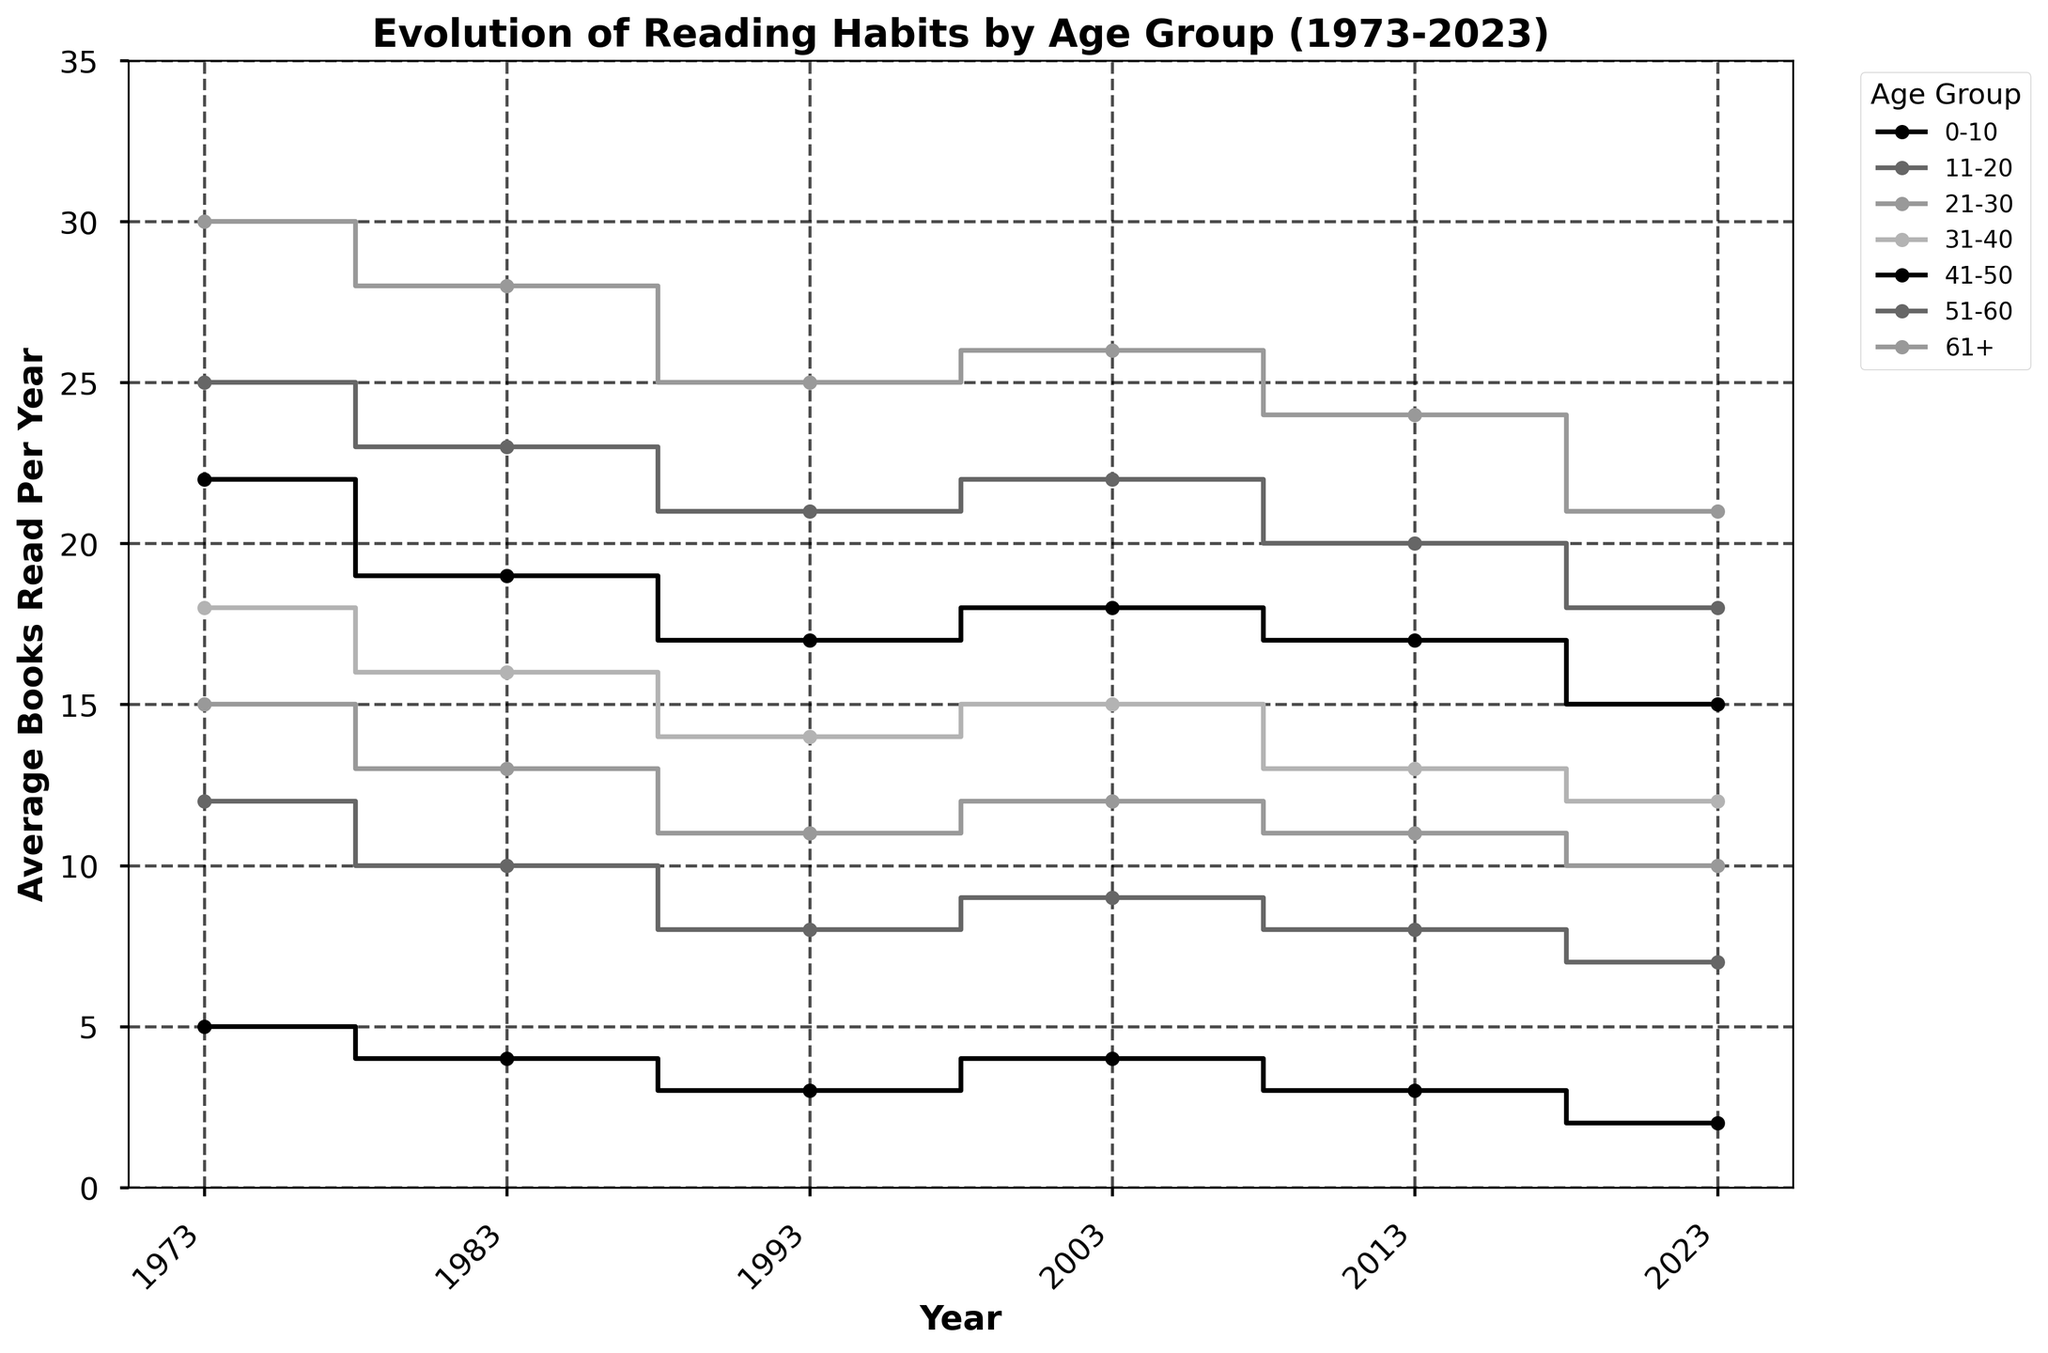What is the title of the plot? The title is displayed at the top of the plot, indicating the main subject of the plot. In this case, it explains the content of the data being visualized.
Answer: Evolution of Reading Habits by Age Group (1973-2023) Which age group reads the most books on average in 2023? To find the age group that reads the most in 2023, locate the 2023 marker on the x-axis and then find the highest data point among the age groups.
Answer: 61+ How has the average number of books read by the 11-20 age group changed from 1973 to 2023? Look at the stair steps for the 11-20 age group on the plot, noting the values at 1973 and 2023, then calculate the difference.
Answer: 12 (1973) to 7 (2023) Which year had the smallest decrease in the average number of books read for the 0-10 age group compared to the previous decade? Identify the values for the 0-10 age group in each decade, then calculate the differences, and find the smallest change.
Answer: 2003 (3 to 4 between 1993 and 2003) On average, how many more books did the 61+ age group read per year in 1983 compared to the 21-30 age group? Find the data points for the 61+ and 21-30 age groups in 1983, then subtract the latter from the former.
Answer: 28 - 13 = 15 In which decade did the average number of books read by the 41-50 age group decline the most? Examine the decline of averages for the 41-50 age group by comparing each successive decade and identify the largest drop.
Answer: 2013-2023 Which age group shows the most consistent reading habits over the 50 years? Assess the fluctuations in the step lines for each age group over the years to see which one has the least variation.
Answer: 0-10 What is the average number of books read per year by the 51-60 age group across all recorded years? Sum the values for the 51-60 age group across all the recorded years and divide by the number of data points (6 decades).
Answer: (25 + 23 + 21 + 22 + 20 + 18) / 6 ≈ 21.5 How does the reading trend for those aged 61+ compare between 1973 and 2023? Compare the beginning (1973) and end (2023) points for the 61+ age group, noting any increase or decrease.
Answer: 30 (1973) to 21 (2023) Which age group's reading habits remained unchanged between any two consecutive decades? Identify any age group whose values remain the same between any two adjacent years.
Answer: 0-10 (2003 and 2013) 